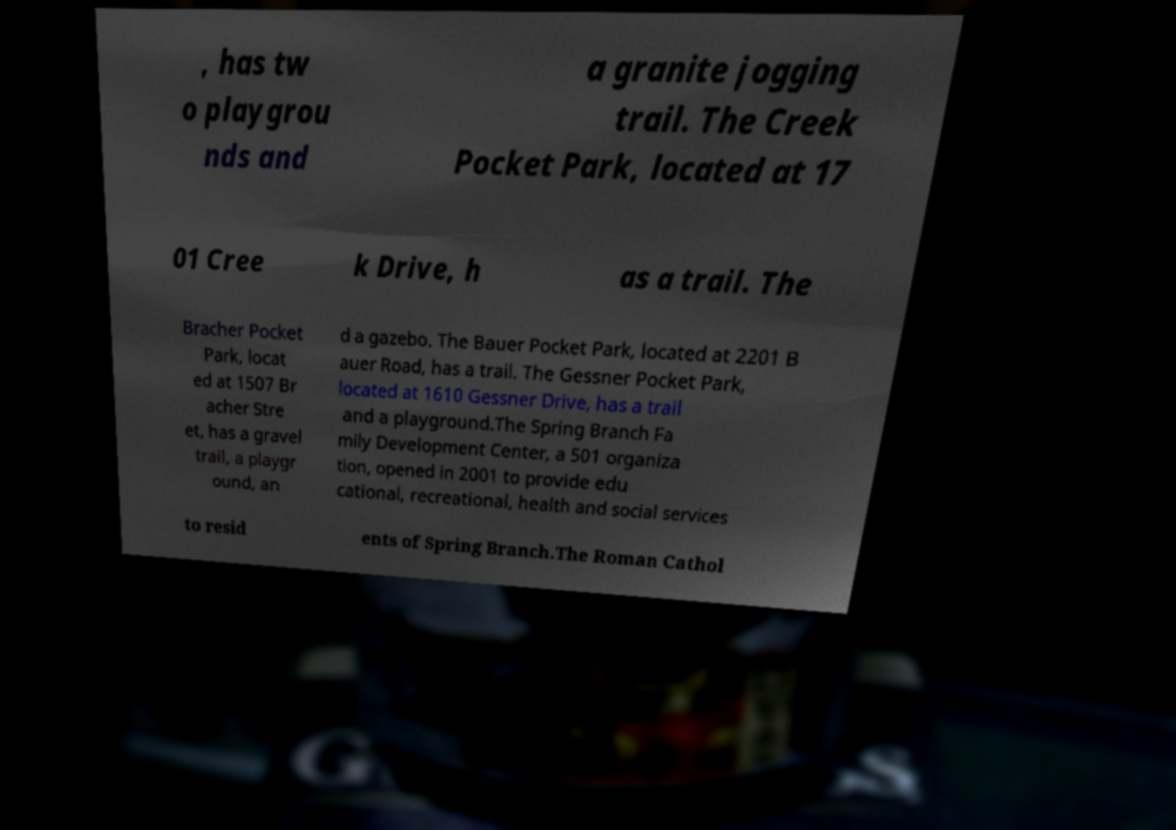Could you extract and type out the text from this image? , has tw o playgrou nds and a granite jogging trail. The Creek Pocket Park, located at 17 01 Cree k Drive, h as a trail. The Bracher Pocket Park, locat ed at 1507 Br acher Stre et, has a gravel trail, a playgr ound, an d a gazebo. The Bauer Pocket Park, located at 2201 B auer Road, has a trail. The Gessner Pocket Park, located at 1610 Gessner Drive, has a trail and a playground.The Spring Branch Fa mily Development Center, a 501 organiza tion, opened in 2001 to provide edu cational, recreational, health and social services to resid ents of Spring Branch.The Roman Cathol 